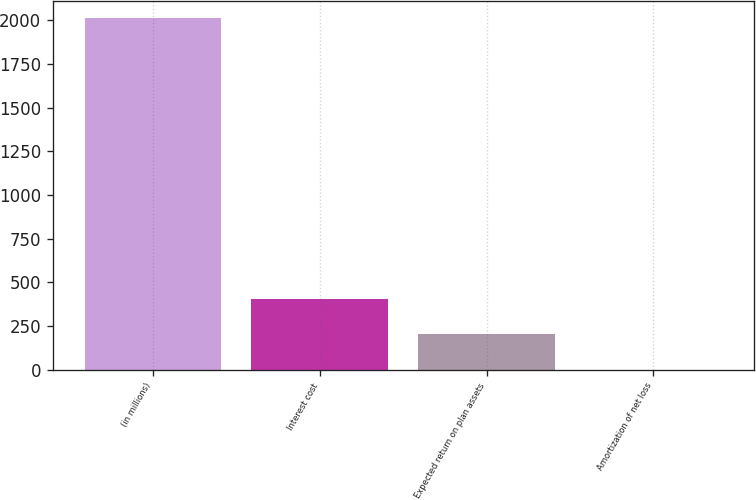<chart> <loc_0><loc_0><loc_500><loc_500><bar_chart><fcel>(in millions)<fcel>Interest cost<fcel>Expected return on plan assets<fcel>Amortization of net loss<nl><fcel>2012<fcel>403.2<fcel>202.1<fcel>1<nl></chart> 